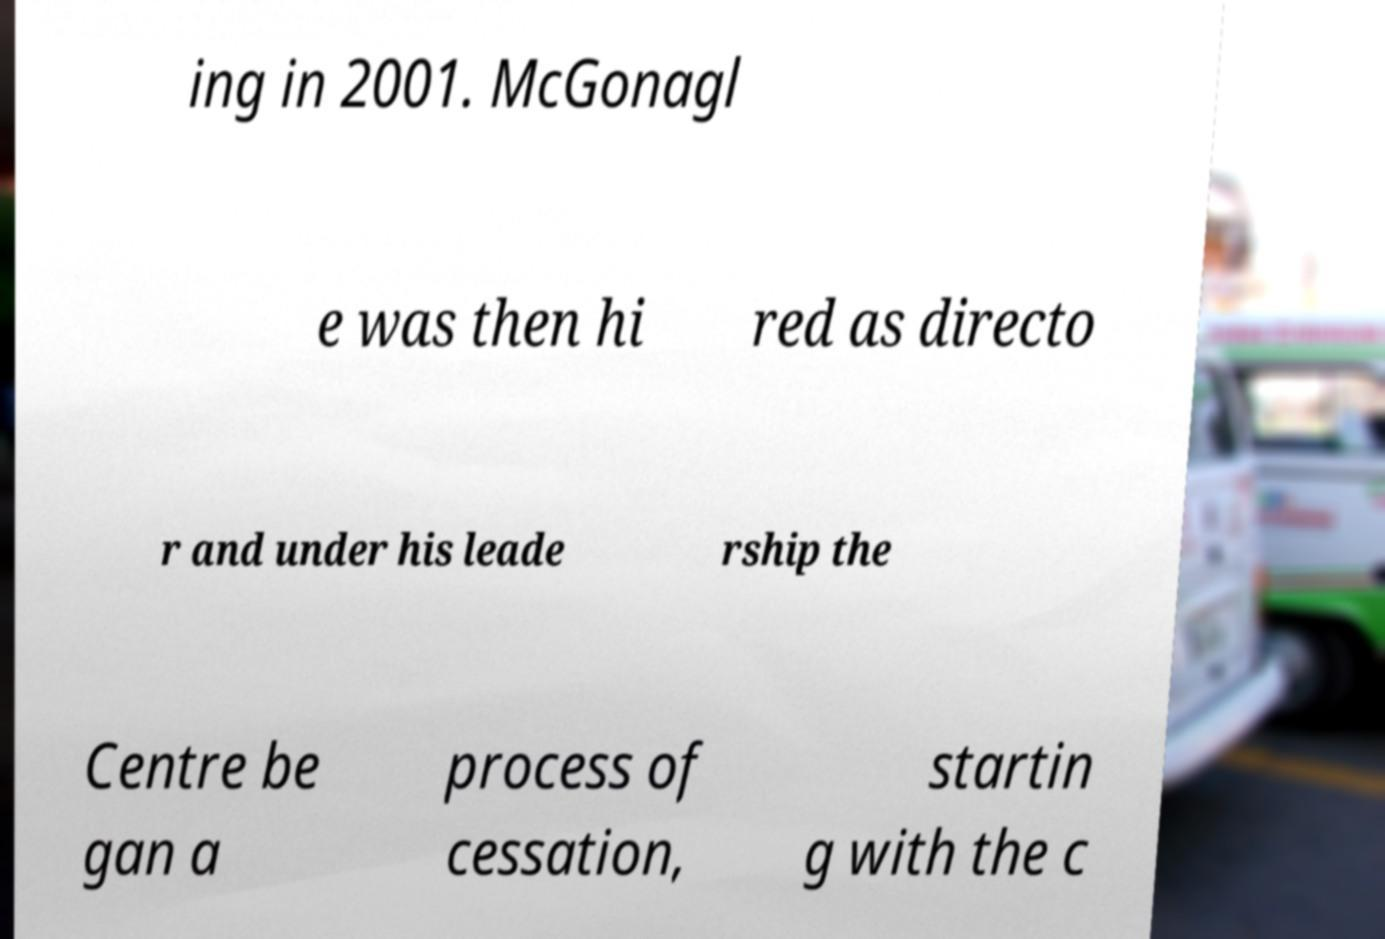Can you accurately transcribe the text from the provided image for me? ing in 2001. McGonagl e was then hi red as directo r and under his leade rship the Centre be gan a process of cessation, startin g with the c 